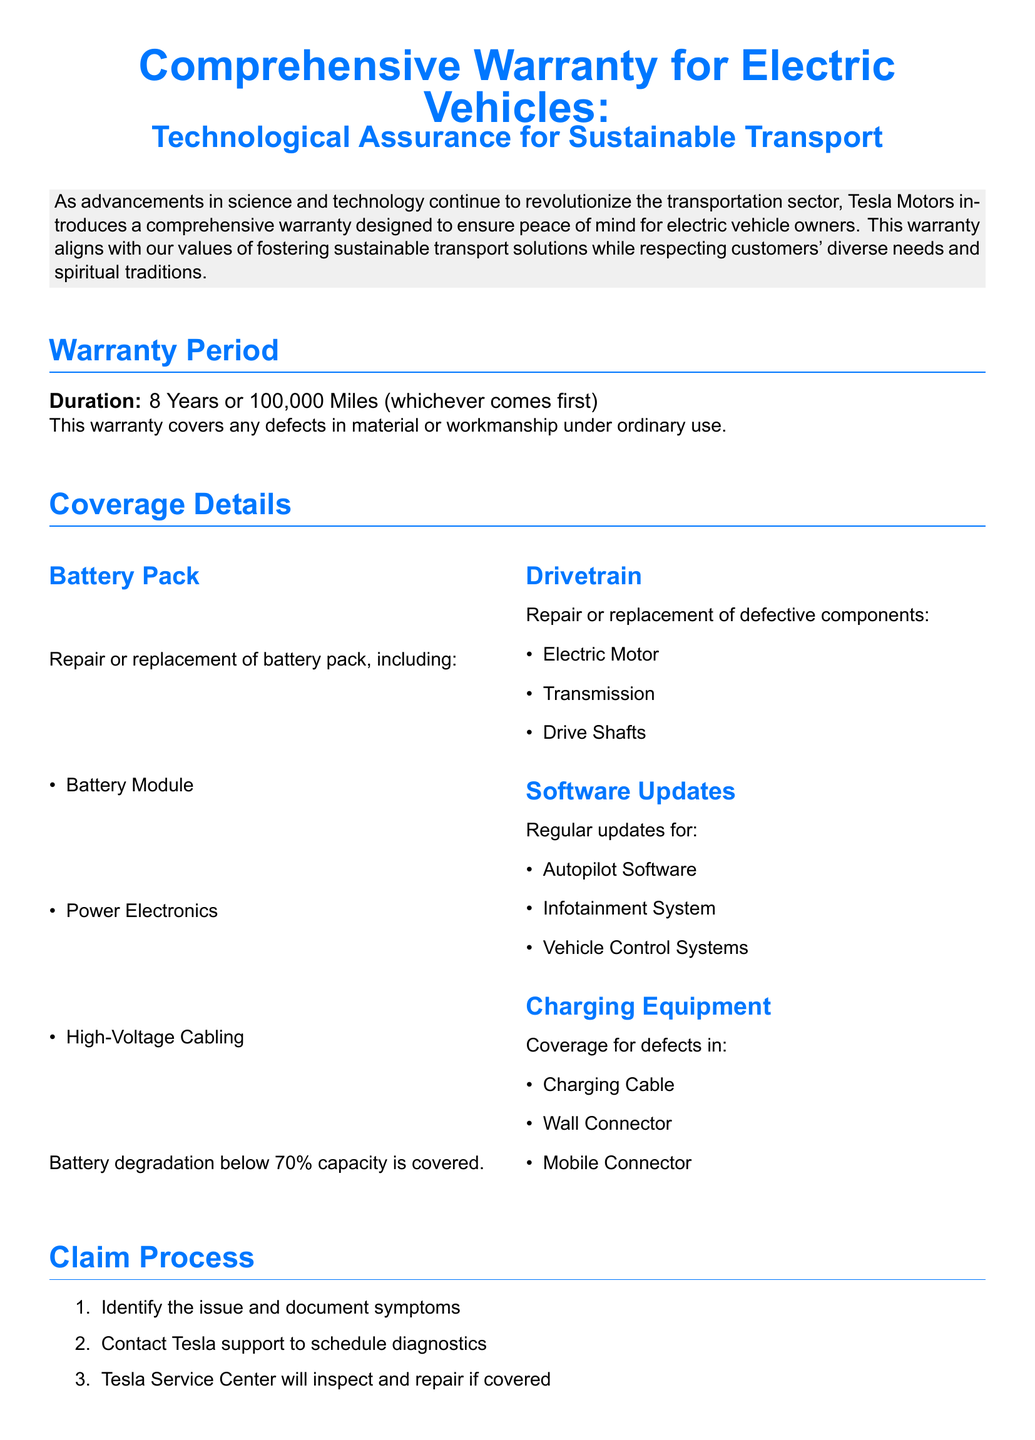What is the duration of the warranty? The warranty duration is clearly stated in the document as 8 Years or 100,000 Miles (whichever comes first).
Answer: 8 Years or 100,000 Miles What does the warranty cover for the battery pack? The document provides a list of components under battery pack coverage, including Battery Module and Power Electronics.
Answer: Battery Module, Power Electronics, High-Voltage Cabling What is the coverage for drivetrain components? The warranty details the components covered under the drivetrain, such as Electric Motor and Transmission.
Answer: Electric Motor, Transmission, Drive Shafts What is excluded from the warranty? The document specifies the exclusions, including damage caused by accidents and unauthorized modifications.
Answer: Accidents, unauthorized modifications, misuse, improper maintenance How are software updates handled under the warranty? The warranty states that regular updates for various systems will be provided, which includes Autopilot Software.
Answer: Autopilot Software, Infotainment System, Vehicle Control Systems What is the process to make a claim? The claim process includes identifying the issue and contacting Tesla support, which is outlined in three steps.
Answer: Identify issue, contact Tesla support, inspect by Service Center What is the battery capacity coverage threshold? The document mentions the condition under which battery degradation is covered.
Answer: Below 70% capacity What is the purpose of the Spiritual Respect Statement? The document includes a statement about Tesla's commitment to respectful interactions based on spiritual beliefs and values.
Answer: Respectful and inclusive manner 